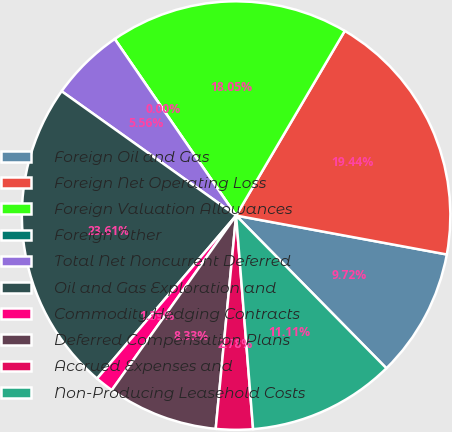Convert chart. <chart><loc_0><loc_0><loc_500><loc_500><pie_chart><fcel>Foreign Oil and Gas<fcel>Foreign Net Operating Loss<fcel>Foreign Valuation Allowances<fcel>Foreign Other<fcel>Total Net Noncurrent Deferred<fcel>Oil and Gas Exploration and<fcel>Commodity Hedging Contracts<fcel>Deferred Compensation Plans<fcel>Accrued Expenses and<fcel>Non-Producing Leasehold Costs<nl><fcel>9.72%<fcel>19.44%<fcel>18.05%<fcel>0.0%<fcel>5.56%<fcel>23.61%<fcel>1.39%<fcel>8.33%<fcel>2.78%<fcel>11.11%<nl></chart> 